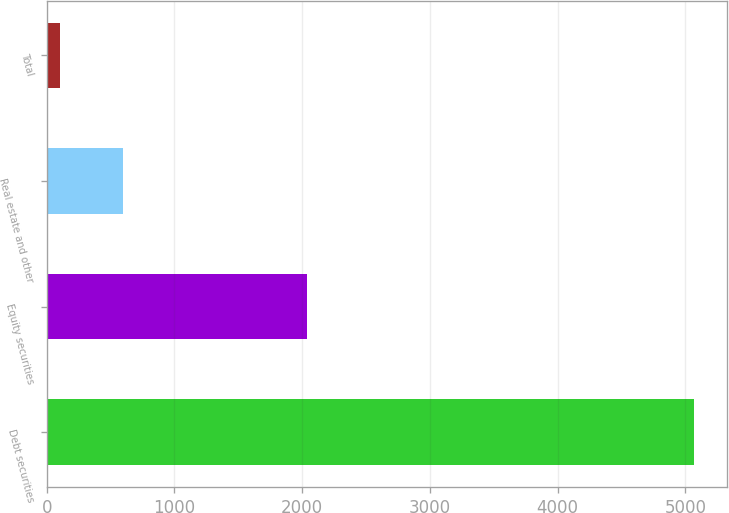Convert chart to OTSL. <chart><loc_0><loc_0><loc_500><loc_500><bar_chart><fcel>Debt securities<fcel>Equity securities<fcel>Real estate and other<fcel>Total<nl><fcel>5070<fcel>2040<fcel>597<fcel>100<nl></chart> 